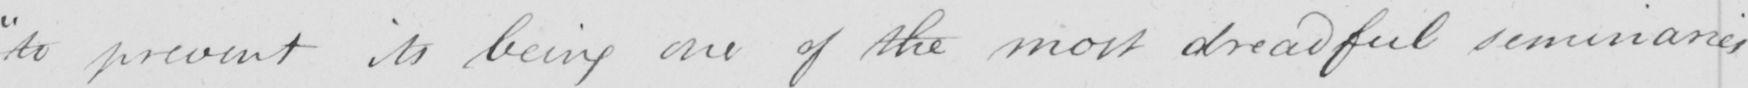Can you tell me what this handwritten text says? " to prevent its being one of the most dreadful seminaries 